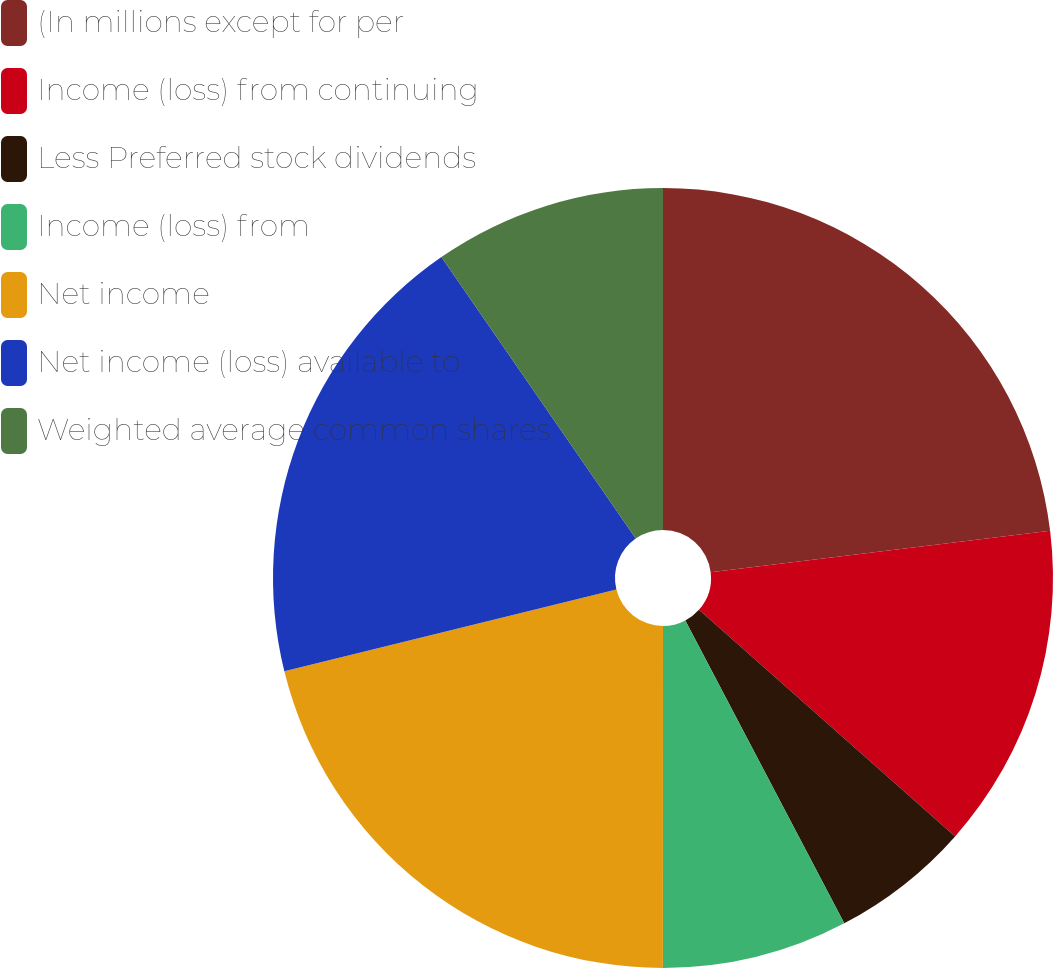Convert chart to OTSL. <chart><loc_0><loc_0><loc_500><loc_500><pie_chart><fcel>(In millions except for per<fcel>Income (loss) from continuing<fcel>Less Preferred stock dividends<fcel>Income (loss) from<fcel>Net income<fcel>Net income (loss) available to<fcel>Weighted average common shares<nl><fcel>23.07%<fcel>13.46%<fcel>5.78%<fcel>7.7%<fcel>21.15%<fcel>19.23%<fcel>9.62%<nl></chart> 